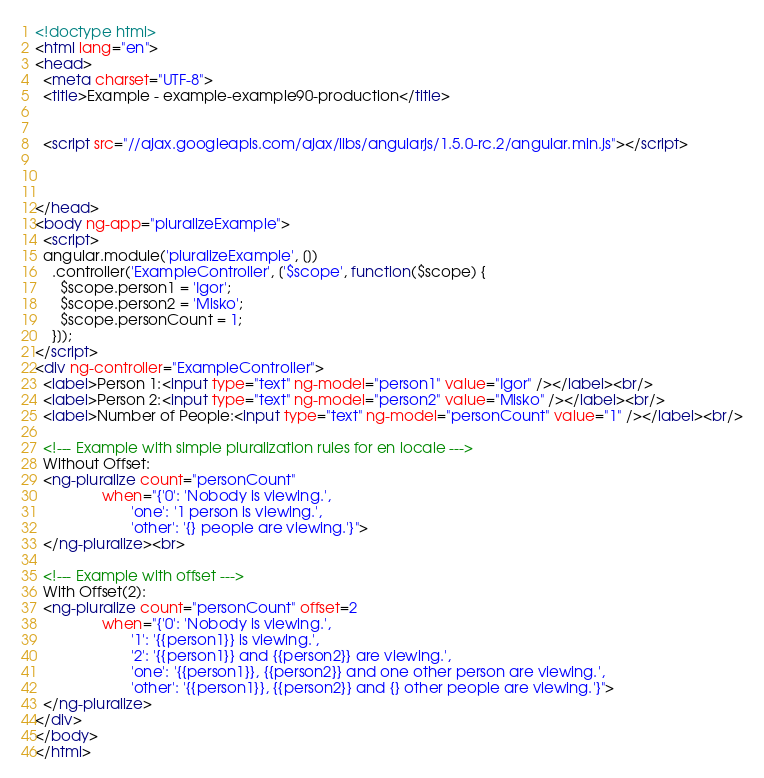<code> <loc_0><loc_0><loc_500><loc_500><_HTML_><!doctype html>
<html lang="en">
<head>
  <meta charset="UTF-8">
  <title>Example - example-example90-production</title>
  

  <script src="//ajax.googleapis.com/ajax/libs/angularjs/1.5.0-rc.2/angular.min.js"></script>
  

  
</head>
<body ng-app="pluralizeExample">
  <script>
  angular.module('pluralizeExample', [])
    .controller('ExampleController', ['$scope', function($scope) {
      $scope.person1 = 'Igor';
      $scope.person2 = 'Misko';
      $scope.personCount = 1;
    }]);
</script>
<div ng-controller="ExampleController">
  <label>Person 1:<input type="text" ng-model="person1" value="Igor" /></label><br/>
  <label>Person 2:<input type="text" ng-model="person2" value="Misko" /></label><br/>
  <label>Number of People:<input type="text" ng-model="personCount" value="1" /></label><br/>

  <!--- Example with simple pluralization rules for en locale --->
  Without Offset:
  <ng-pluralize count="personCount"
                when="{'0': 'Nobody is viewing.',
                       'one': '1 person is viewing.',
                       'other': '{} people are viewing.'}">
  </ng-pluralize><br>

  <!--- Example with offset --->
  With Offset(2):
  <ng-pluralize count="personCount" offset=2
                when="{'0': 'Nobody is viewing.',
                       '1': '{{person1}} is viewing.',
                       '2': '{{person1}} and {{person2}} are viewing.',
                       'one': '{{person1}}, {{person2}} and one other person are viewing.',
                       'other': '{{person1}}, {{person2}} and {} other people are viewing.'}">
  </ng-pluralize>
</div>
</body>
</html></code> 